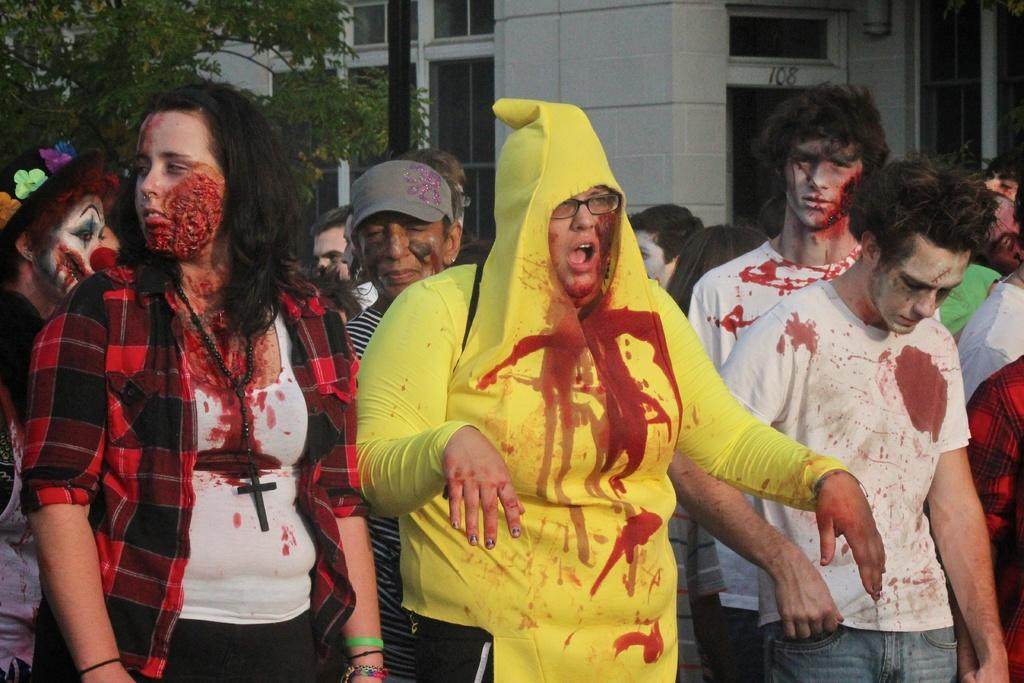How many people are in the image? There is a group of people in the image. What are the people wearing? The people are wearing fancy dresses. What are the people doing in the image? The people are standing. What can be seen in the background of the image? There is a building, trees, and a pole in the background of the image. What type of house is visible in the image? There is no house visible in the image; only a building, trees, and a pole can be seen in the background. 